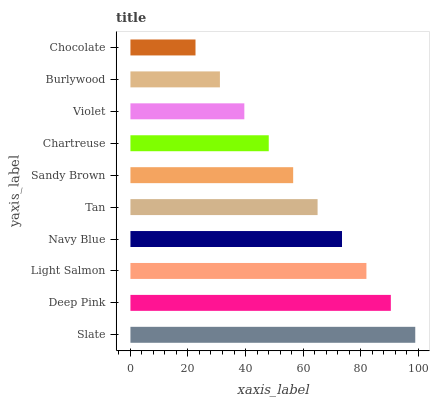Is Chocolate the minimum?
Answer yes or no. Yes. Is Slate the maximum?
Answer yes or no. Yes. Is Deep Pink the minimum?
Answer yes or no. No. Is Deep Pink the maximum?
Answer yes or no. No. Is Slate greater than Deep Pink?
Answer yes or no. Yes. Is Deep Pink less than Slate?
Answer yes or no. Yes. Is Deep Pink greater than Slate?
Answer yes or no. No. Is Slate less than Deep Pink?
Answer yes or no. No. Is Tan the high median?
Answer yes or no. Yes. Is Sandy Brown the low median?
Answer yes or no. Yes. Is Light Salmon the high median?
Answer yes or no. No. Is Deep Pink the low median?
Answer yes or no. No. 